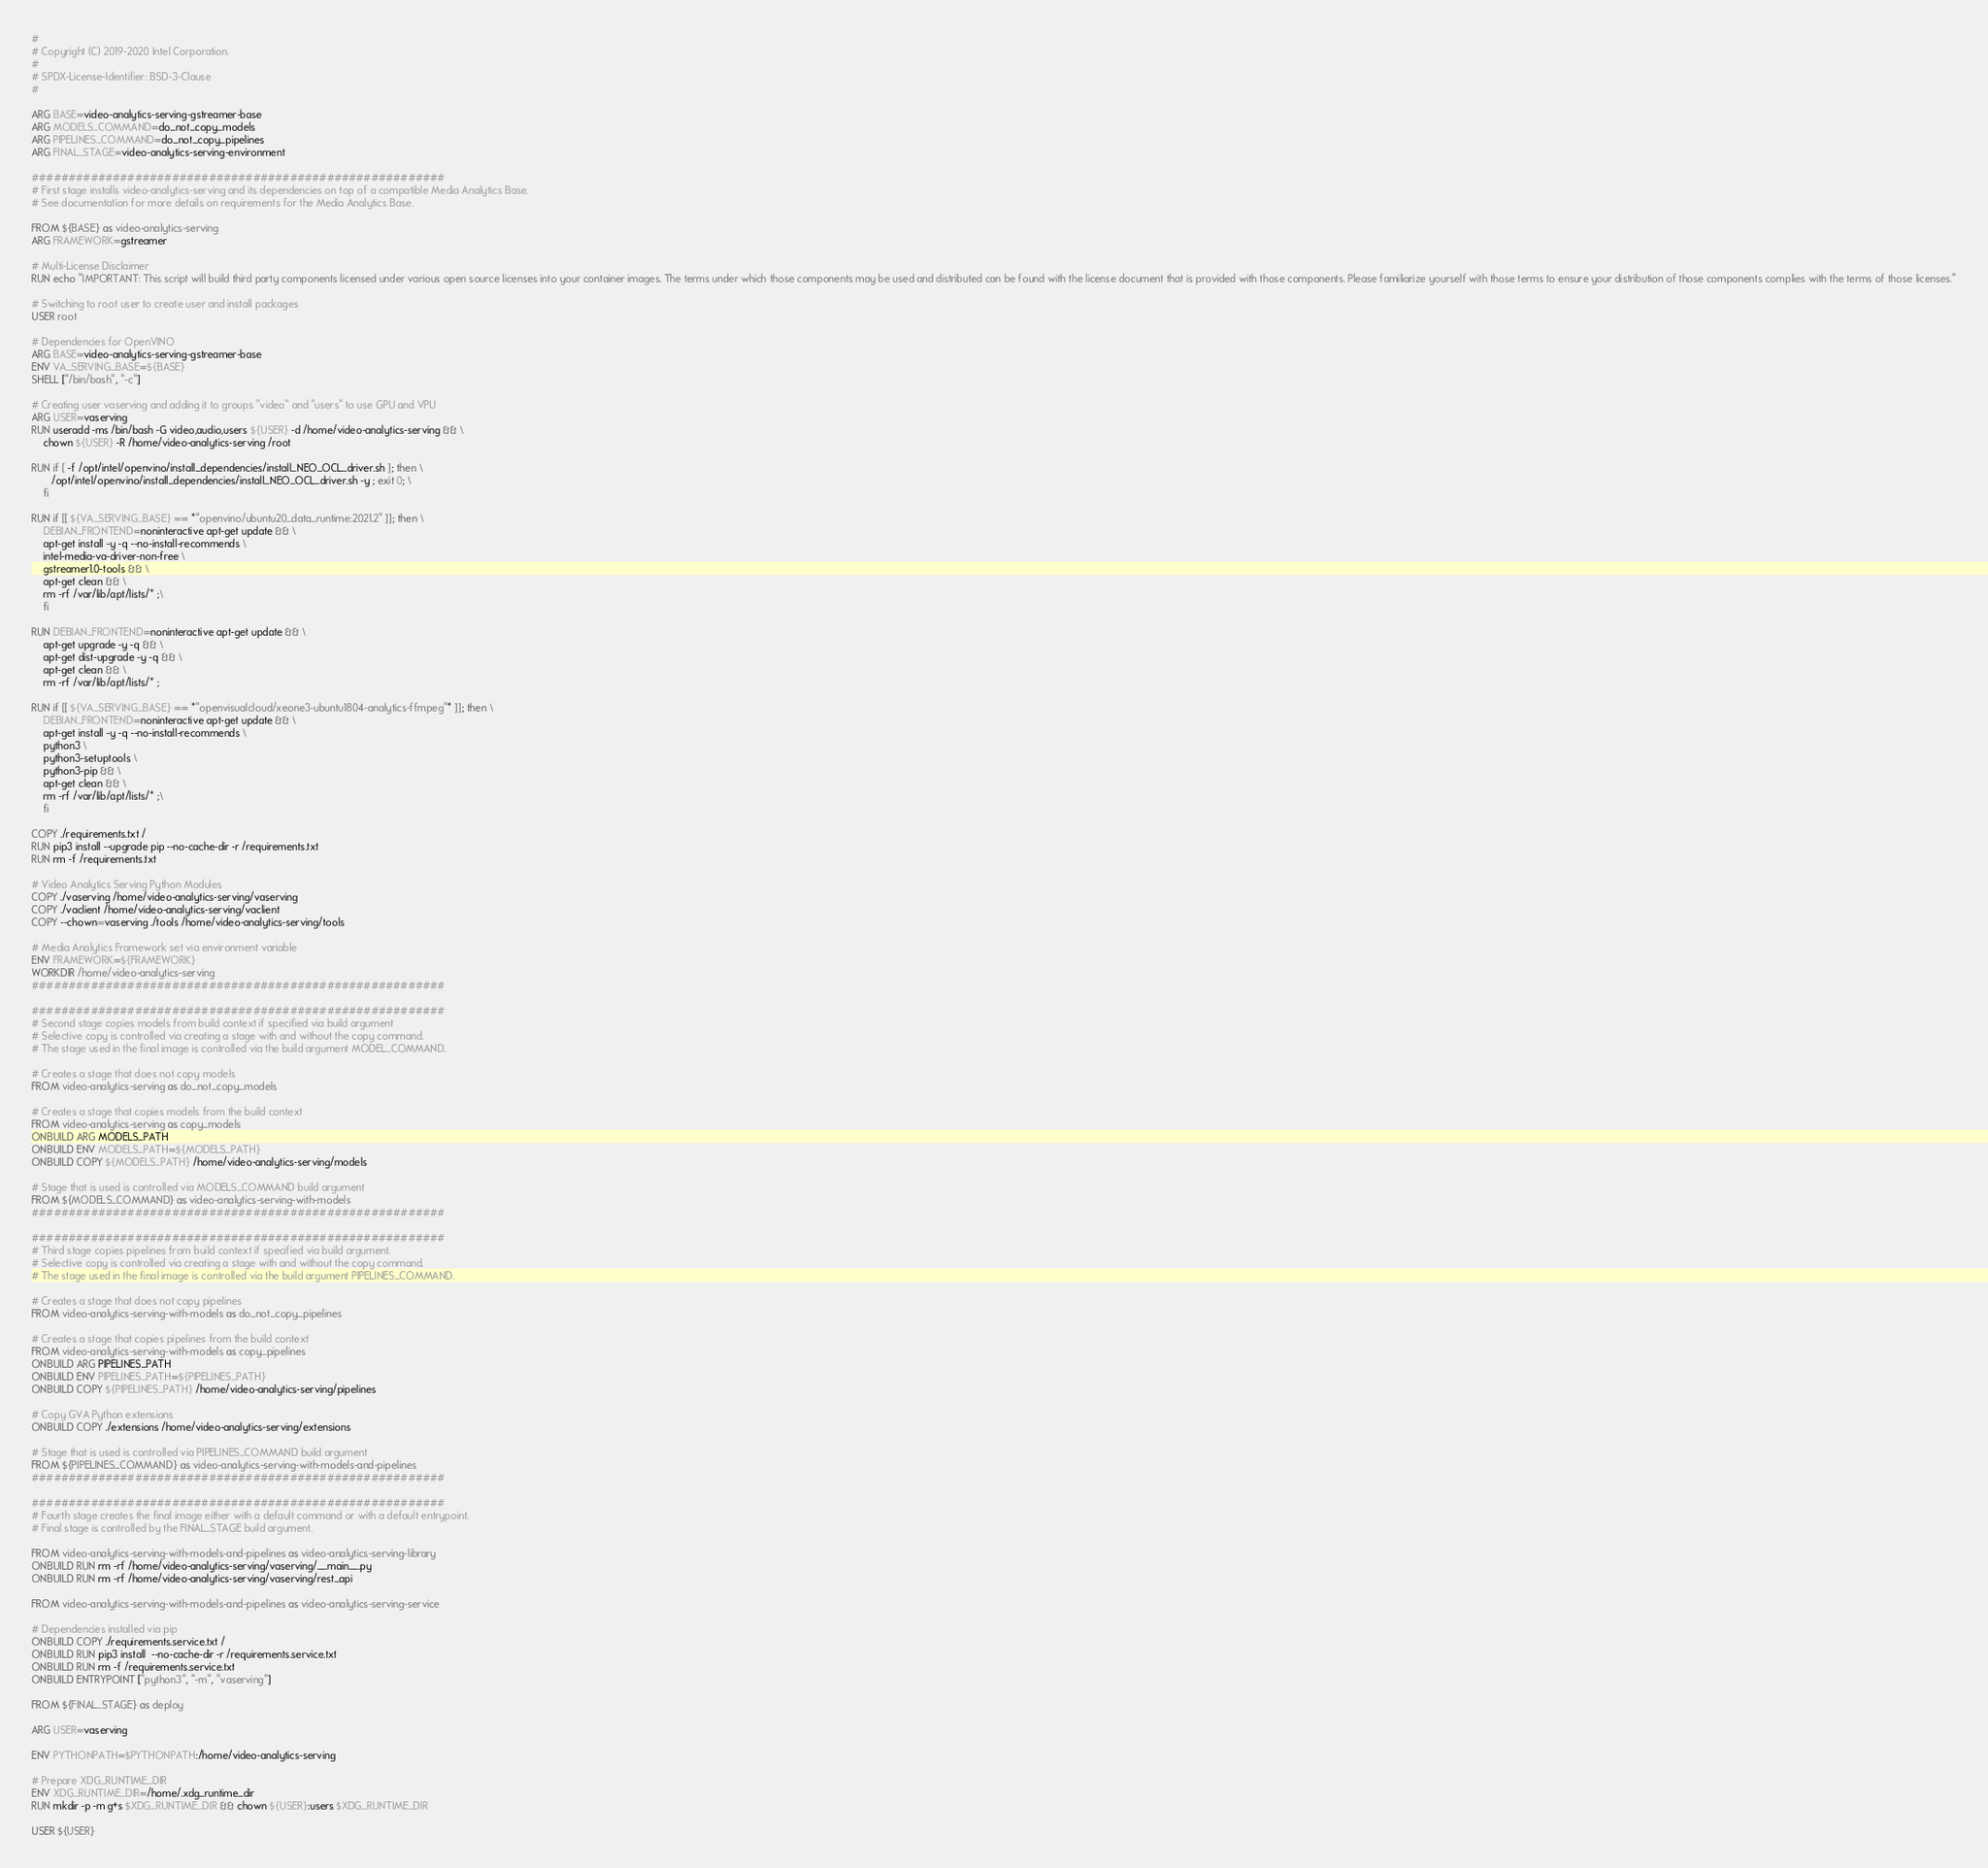<code> <loc_0><loc_0><loc_500><loc_500><_Dockerfile_>#
# Copyright (C) 2019-2020 Intel Corporation.
#
# SPDX-License-Identifier: BSD-3-Clause
#

ARG BASE=video-analytics-serving-gstreamer-base
ARG MODELS_COMMAND=do_not_copy_models
ARG PIPELINES_COMMAND=do_not_copy_pipelines
ARG FINAL_STAGE=video-analytics-serving-environment

########################################################
# First stage installs video-analytics-serving and its dependencies on top of a compatible Media Analytics Base.
# See documentation for more details on requirements for the Media Analytics Base.

FROM ${BASE} as video-analytics-serving
ARG FRAMEWORK=gstreamer

# Multi-License Disclaimer
RUN echo "IMPORTANT: This script will build third party components licensed under various open source licenses into your container images. The terms under which those components may be used and distributed can be found with the license document that is provided with those components. Please familiarize yourself with those terms to ensure your distribution of those components complies with the terms of those licenses."

# Switching to root user to create user and install packages
USER root

# Dependencies for OpenVINO
ARG BASE=video-analytics-serving-gstreamer-base
ENV VA_SERVING_BASE=${BASE}
SHELL ["/bin/bash", "-c"]

# Creating user vaserving and adding it to groups "video" and "users" to use GPU and VPU
ARG USER=vaserving
RUN useradd -ms /bin/bash -G video,audio,users ${USER} -d /home/video-analytics-serving && \
    chown ${USER} -R /home/video-analytics-serving /root

RUN if [ -f /opt/intel/openvino/install_dependencies/install_NEO_OCL_driver.sh ]; then \
       /opt/intel/openvino/install_dependencies/install_NEO_OCL_driver.sh -y ; exit 0; \
    fi

RUN if [[ ${VA_SERVING_BASE} == *"openvino/ubuntu20_data_runtime:2021.2" ]]; then \
    DEBIAN_FRONTEND=noninteractive apt-get update && \
    apt-get install -y -q --no-install-recommends \
    intel-media-va-driver-non-free \
    gstreamer1.0-tools && \
    apt-get clean && \
    rm -rf /var/lib/apt/lists/* ;\
    fi

RUN DEBIAN_FRONTEND=noninteractive apt-get update && \
    apt-get upgrade -y -q && \
    apt-get dist-upgrade -y -q && \
    apt-get clean && \
    rm -rf /var/lib/apt/lists/* ;

RUN if [[ ${VA_SERVING_BASE} == *"openvisualcloud/xeone3-ubuntu1804-analytics-ffmpeg"* ]]; then \
    DEBIAN_FRONTEND=noninteractive apt-get update && \
    apt-get install -y -q --no-install-recommends \
    python3 \
    python3-setuptools \
    python3-pip && \
    apt-get clean && \
    rm -rf /var/lib/apt/lists/* ;\
    fi

COPY ./requirements.txt /
RUN pip3 install --upgrade pip --no-cache-dir -r /requirements.txt
RUN rm -f /requirements.txt

# Video Analytics Serving Python Modules
COPY ./vaserving /home/video-analytics-serving/vaserving
COPY ./vaclient /home/video-analytics-serving/vaclient
COPY --chown=vaserving ./tools /home/video-analytics-serving/tools

# Media Analytics Framework set via environment variable
ENV FRAMEWORK=${FRAMEWORK}
WORKDIR /home/video-analytics-serving
########################################################

########################################################
# Second stage copies models from build context if specified via build argument
# Selective copy is controlled via creating a stage with and without the copy command.
# The stage used in the final image is controlled via the build argument MODEL_COMMAND.

# Creates a stage that does not copy models
FROM video-analytics-serving as do_not_copy_models

# Creates a stage that copies models from the build context
FROM video-analytics-serving as copy_models
ONBUILD ARG MODELS_PATH
ONBUILD ENV MODELS_PATH=${MODELS_PATH}
ONBUILD COPY ${MODELS_PATH} /home/video-analytics-serving/models

# Stage that is used is controlled via MODELS_COMMAND build argument
FROM ${MODELS_COMMAND} as video-analytics-serving-with-models
########################################################

########################################################
# Third stage copies pipelines from build context if specified via build argument.
# Selective copy is controlled via creating a stage with and without the copy command.
# The stage used in the final image is controlled via the build argument PIPELINES_COMMAND.

# Creates a stage that does not copy pipelines
FROM video-analytics-serving-with-models as do_not_copy_pipelines

# Creates a stage that copies pipelines from the build context
FROM video-analytics-serving-with-models as copy_pipelines
ONBUILD ARG PIPELINES_PATH
ONBUILD ENV PIPELINES_PATH=${PIPELINES_PATH}
ONBUILD COPY ${PIPELINES_PATH} /home/video-analytics-serving/pipelines

# Copy GVA Python extensions
ONBUILD COPY ./extensions /home/video-analytics-serving/extensions

# Stage that is used is controlled via PIPELINES_COMMAND build argument
FROM ${PIPELINES_COMMAND} as video-analytics-serving-with-models-and-pipelines
########################################################

########################################################
# Fourth stage creates the final image either with a default command or with a default entrypoint.
# Final stage is controlled by the FINAL_STAGE build argument.

FROM video-analytics-serving-with-models-and-pipelines as video-analytics-serving-library
ONBUILD RUN rm -rf /home/video-analytics-serving/vaserving/__main__.py
ONBUILD RUN rm -rf /home/video-analytics-serving/vaserving/rest_api

FROM video-analytics-serving-with-models-and-pipelines as video-analytics-serving-service

# Dependencies installed via pip
ONBUILD COPY ./requirements.service.txt /
ONBUILD RUN pip3 install  --no-cache-dir -r /requirements.service.txt
ONBUILD RUN rm -f /requirements.service.txt
ONBUILD ENTRYPOINT ["python3", "-m", "vaserving"]

FROM ${FINAL_STAGE} as deploy

ARG USER=vaserving

ENV PYTHONPATH=$PYTHONPATH:/home/video-analytics-serving

# Prepare XDG_RUNTIME_DIR
ENV XDG_RUNTIME_DIR=/home/.xdg_runtime_dir
RUN mkdir -p -m g+s $XDG_RUNTIME_DIR && chown ${USER}:users $XDG_RUNTIME_DIR

USER ${USER}
</code> 